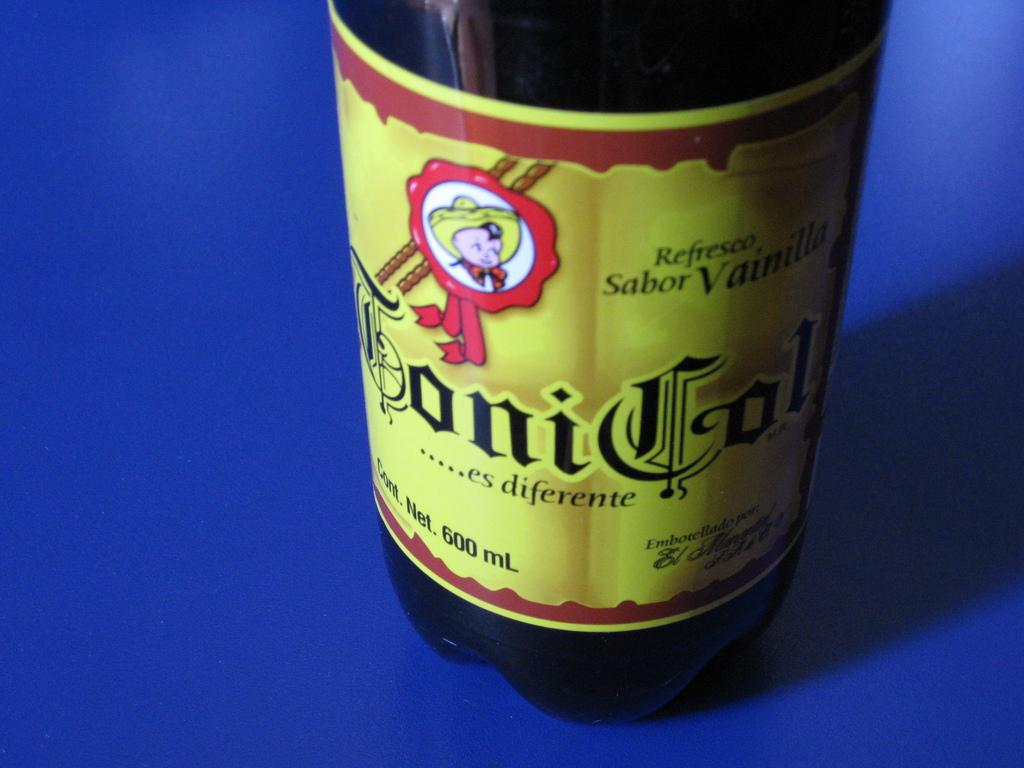What brand of alcohol is this?
Make the answer very short. Unanswerable. How many ml is the bottle?
Offer a very short reply. 600. 